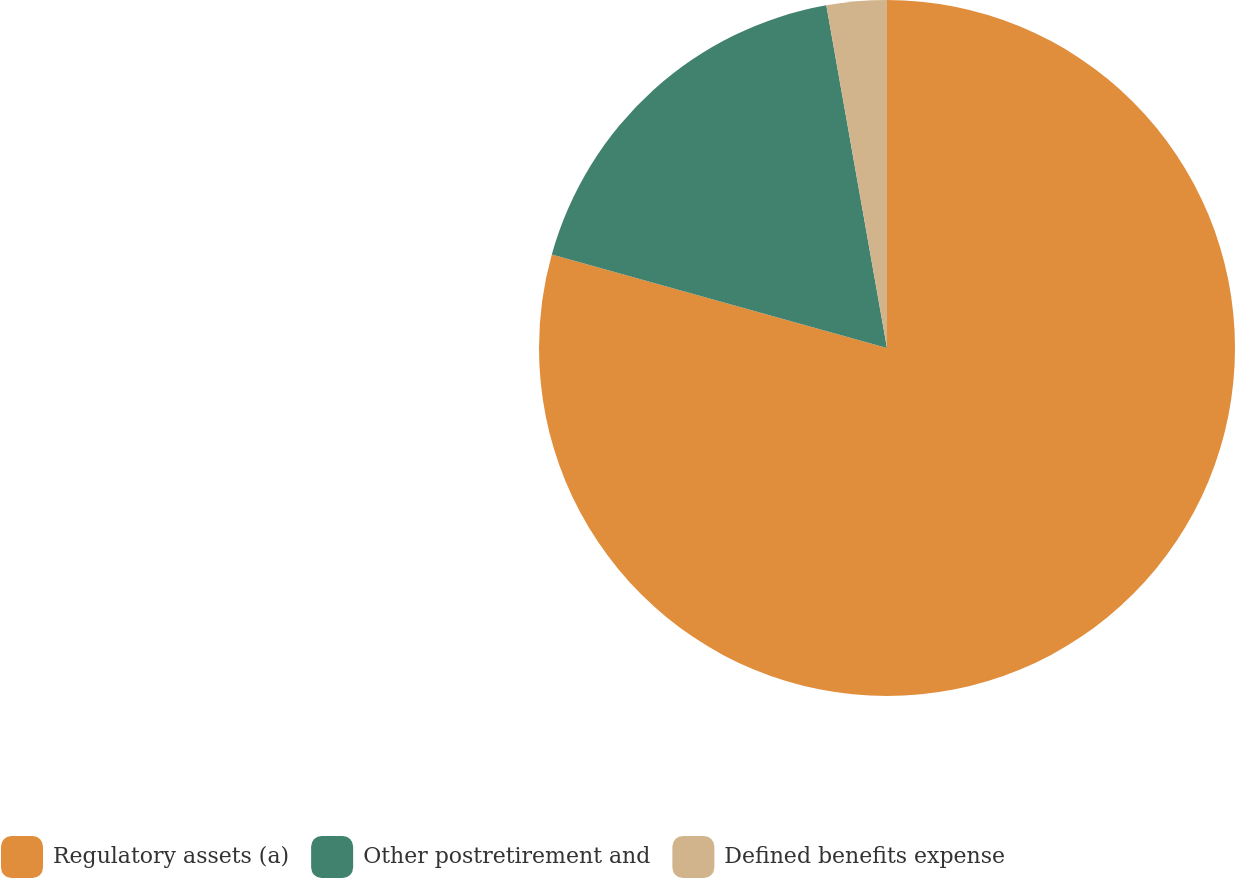<chart> <loc_0><loc_0><loc_500><loc_500><pie_chart><fcel>Regulatory assets (a)<fcel>Other postretirement and<fcel>Defined benefits expense<nl><fcel>79.33%<fcel>17.88%<fcel>2.79%<nl></chart> 